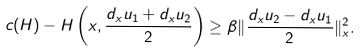<formula> <loc_0><loc_0><loc_500><loc_500>c ( H ) - H \left ( x , \frac { d _ { x } u _ { 1 } + d _ { x } u _ { 2 } } 2 \right ) \geq \beta \| \frac { d _ { x } u _ { 2 } - d _ { x } u _ { 1 } } 2 \| _ { x } ^ { 2 } .</formula> 